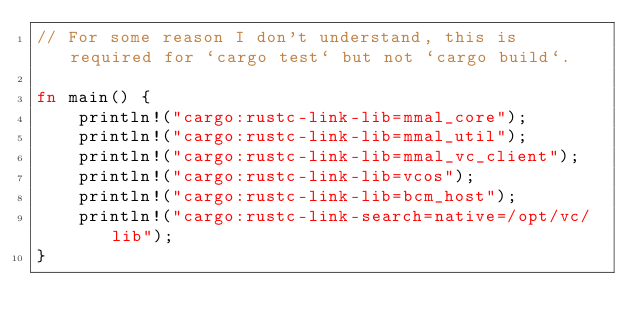<code> <loc_0><loc_0><loc_500><loc_500><_Rust_>// For some reason I don't understand, this is required for `cargo test` but not `cargo build`.

fn main() {
    println!("cargo:rustc-link-lib=mmal_core");
    println!("cargo:rustc-link-lib=mmal_util");
    println!("cargo:rustc-link-lib=mmal_vc_client");
    println!("cargo:rustc-link-lib=vcos");
    println!("cargo:rustc-link-lib=bcm_host");
    println!("cargo:rustc-link-search=native=/opt/vc/lib");
}
</code> 